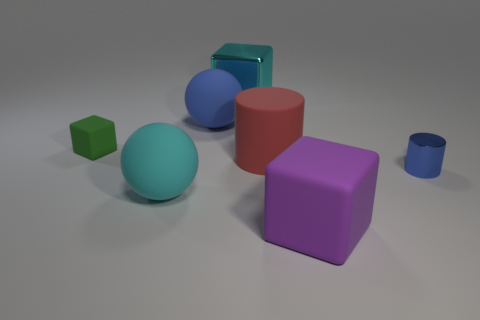How many objects are there in the image? There are six objects in the image, which include a mix of geometric shapes such as cubes, spheres, and cylinders. Which object is the largest? The largest object appears to be the red cube, based on its comparative size to the other objects in the image. 